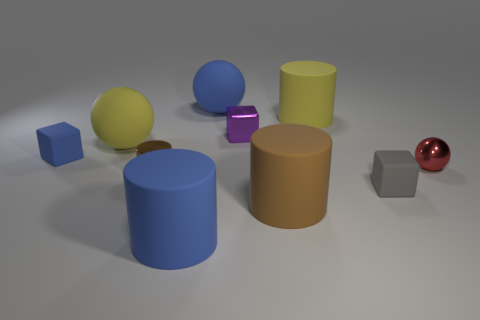What shape is the matte thing that is the same color as the tiny metal cylinder?
Provide a succinct answer. Cylinder. Is the number of tiny matte things that are in front of the metal sphere greater than the number of big rubber spheres that are on the right side of the large brown rubber thing?
Provide a short and direct response. Yes. Do the yellow object that is to the left of the metal block and the yellow thing that is behind the tiny purple shiny object have the same material?
Offer a terse response. Yes. There is a small red metallic ball; are there any small purple blocks in front of it?
Ensure brevity in your answer.  No. What number of yellow objects are big metallic cylinders or matte blocks?
Your answer should be very brief. 0. Is the material of the small blue object the same as the large cylinder behind the gray thing?
Your answer should be compact. Yes. What size is the gray object that is the same shape as the tiny purple shiny object?
Your response must be concise. Small. What material is the tiny gray object?
Provide a short and direct response. Rubber. What is the material of the brown object in front of the rubber block on the right side of the small block that is to the left of the tiny brown cylinder?
Give a very brief answer. Rubber. Is the size of the brown thing that is right of the large blue rubber sphere the same as the yellow object to the left of the big blue rubber cylinder?
Your answer should be very brief. Yes. 